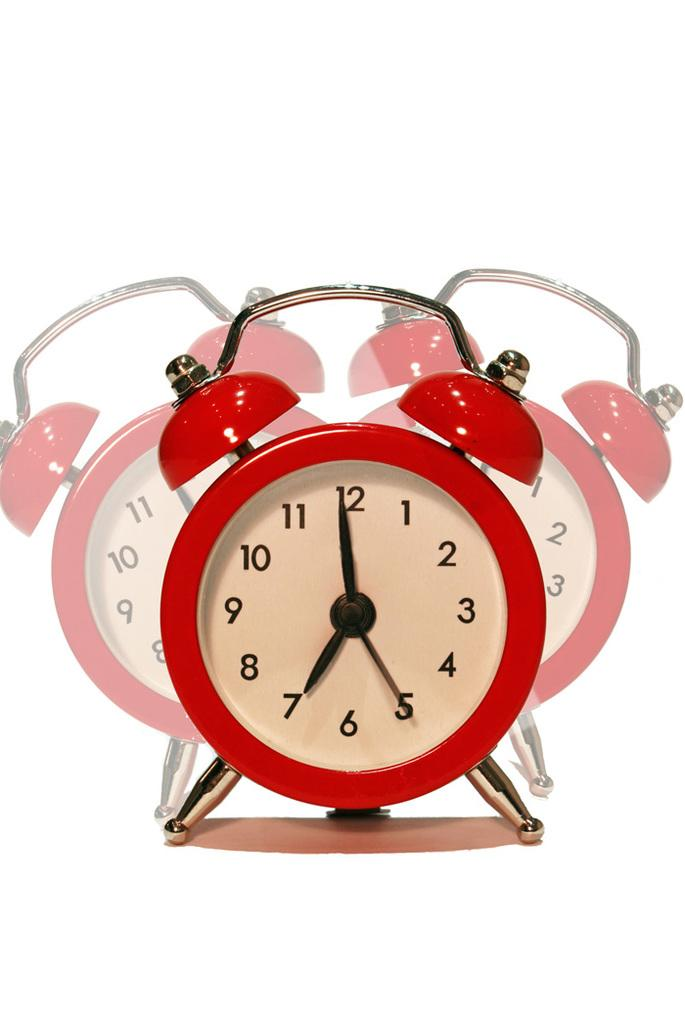Provide a one-sentence caption for the provided image. A red alarm clock that is showing the time of 7:00. 